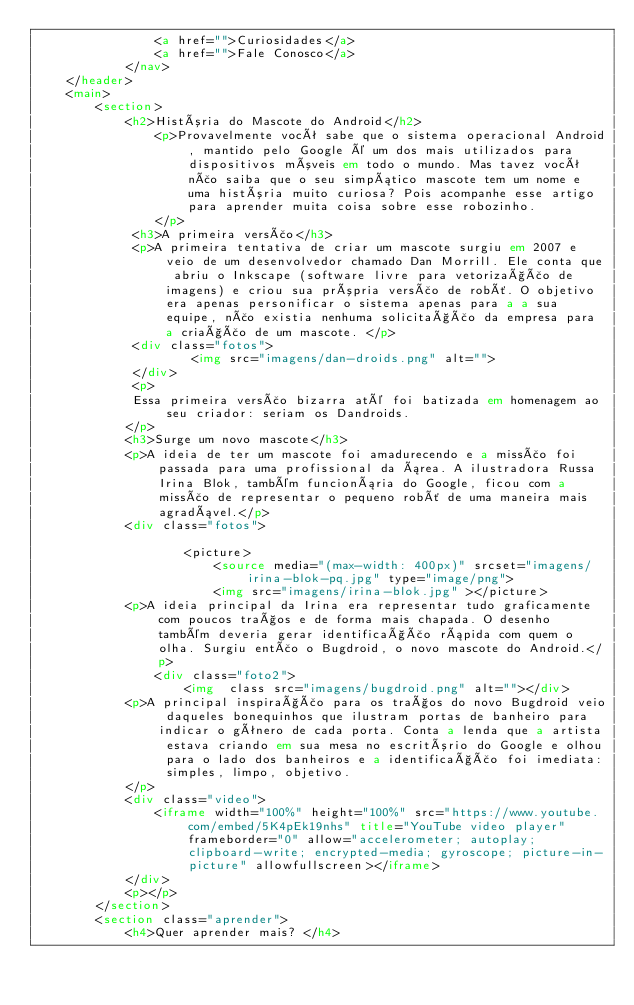Convert code to text. <code><loc_0><loc_0><loc_500><loc_500><_HTML_>                <a href="">Curiosidades</a>
                <a href="">Fale Conosco</a>
            </nav>
    </header>
    <main>
        <section>
            <h2>História do Mascote do Android</h2>
                <p>Provavelmente você sabe que o sistema operacional Android, mantido pelo Google é um dos mais utilizados para dispositivos móveis em todo o mundo. Mas tavez você não saiba que o seu simpático mascote tem um nome e uma história muito curiosa? Pois acompanhe esse artigo para aprender muita coisa sobre esse robozinho.
                </p>
             <h3>A primeira versão</h3>
             <p>A primeira tentativa de criar um mascote surgiu em 2007 e veio de um desenvolvedor chamado Dan Morrill. Ele conta que abriu o Inkscape (software livre para vetorização de imagens) e criou sua própria versão de robô. O objetivo era apenas personificar o sistema apenas para a a sua equipe, não existia nenhuma solicitação da empresa para a criação de um mascote. </p>
             <div class="fotos">
                     <img src="imagens/dan-droids.png" alt="">
             </div>
             <p>
             Essa primeira versão bizarra até foi batizada em homenagem ao seu criador: seriam os Dandroids.
            </p>
            <h3>Surge um novo mascote</h3>
            <p>A ideia de ter um mascote foi amadurecendo e a missão foi passada para uma profissional da área. A ilustradora Russa Irina Blok, também funcionária do Google, ficou com a missão de representar o pequeno robô de uma maneira mais agradável.</p>
            <div class="fotos">
 
                    <picture>
                        <source media="(max-width: 400px)" srcset="imagens/irina-blok-pq.jpg" type="image/png">
                        <img src="imagens/irina-blok.jpg" ></picture>
            <p>A ideia principal da Irina era representar tudo graficamente com poucos traços e de forma mais chapada. O desenho também deveria gerar identificação rápida com quem o olha. Surgiu então o Bugdroid, o novo mascote do Android.</p>
                <div class="foto2">
                    <img  class src="imagens/bugdroid.png" alt=""></div>
            <p>A principal inspiração para os traços do novo Bugdroid veio daqueles bonequinhos que ilustram portas de banheiro para indicar o gênero de cada porta. Conta a lenda que a artista estava criando em sua mesa no escritório do Google e olhou para o lado dos banheiros e a identificação foi imediata: simples, limpo, objetivo.
            </p>
            <div class="video">
                <iframe width="100%" height="100%" src="https://www.youtube.com/embed/5K4pEk19nhs" title="YouTube video player" frameborder="0" allow="accelerometer; autoplay; clipboard-write; encrypted-media; gyroscope; picture-in-picture" allowfullscreen></iframe>
            </div>
            <p></p>
        </section>
        <section class="aprender">
            <h4>Quer aprender mais? </h4></code> 